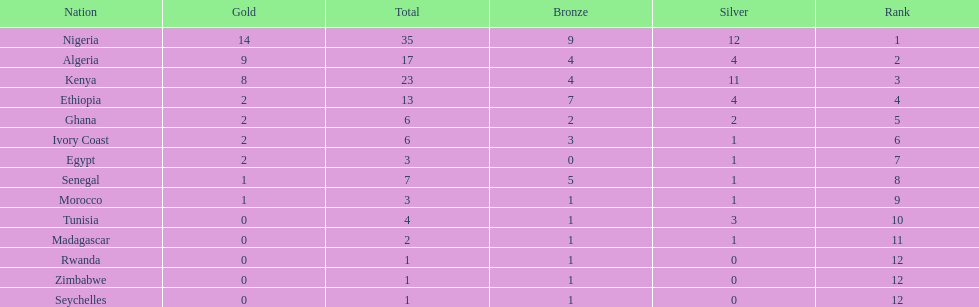What was the total number of medals the ivory coast won? 6. 